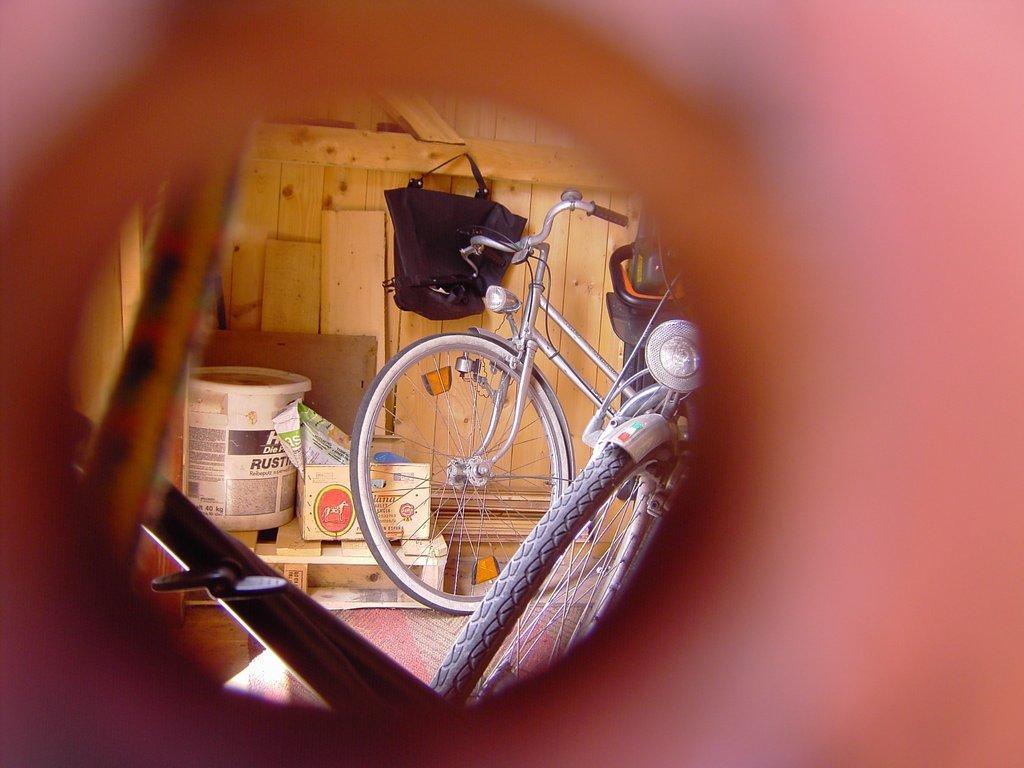How would you summarize this image in a sentence or two? Here there is bicycle, box, container, bag, wooden object is present. 